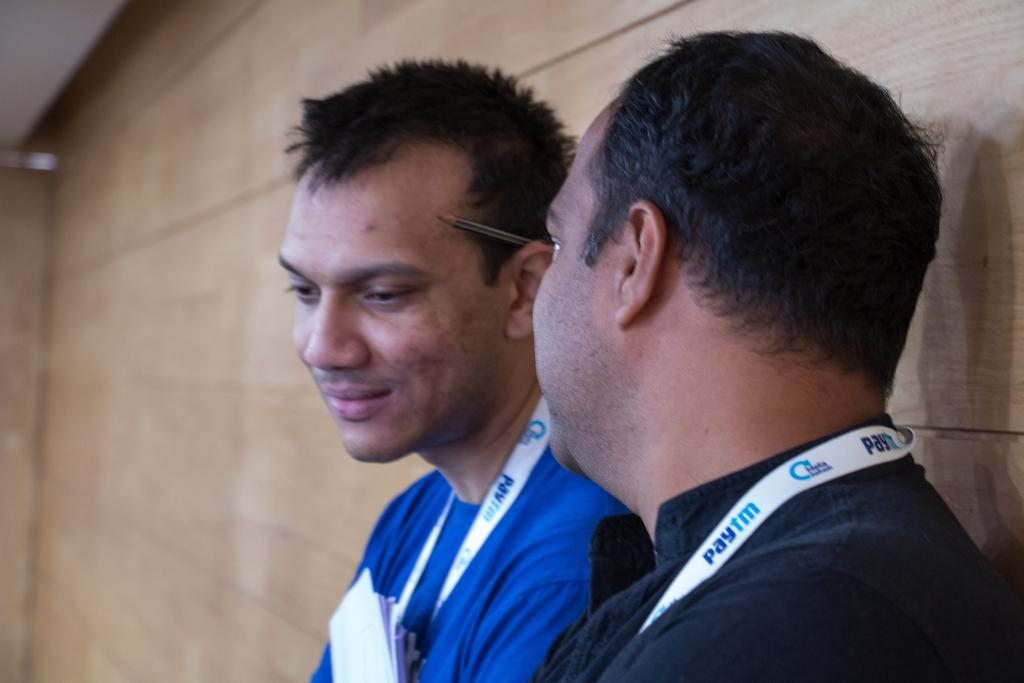<image>
Write a terse but informative summary of the picture. Two men are sitting together and both are wearing lanyards that say "paytm" on them. 